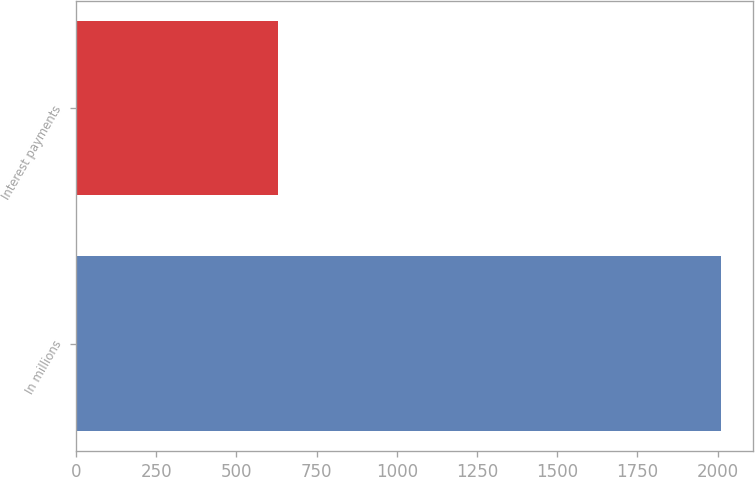Convert chart. <chart><loc_0><loc_0><loc_500><loc_500><bar_chart><fcel>In millions<fcel>Interest payments<nl><fcel>2011<fcel>629<nl></chart> 